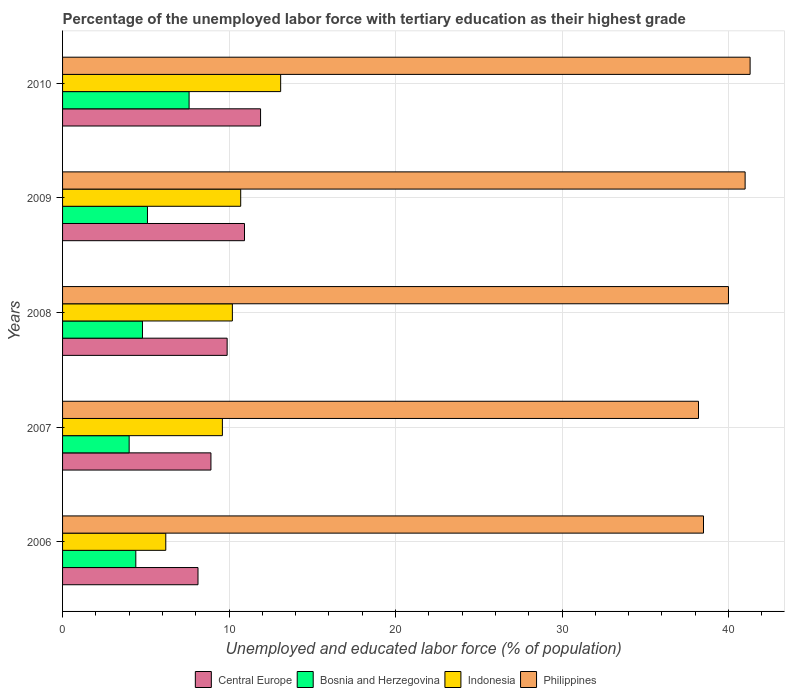How many different coloured bars are there?
Offer a terse response. 4. Are the number of bars per tick equal to the number of legend labels?
Your response must be concise. Yes. Are the number of bars on each tick of the Y-axis equal?
Provide a short and direct response. Yes. How many bars are there on the 2nd tick from the top?
Provide a succinct answer. 4. What is the percentage of the unemployed labor force with tertiary education in Philippines in 2007?
Keep it short and to the point. 38.2. Across all years, what is the maximum percentage of the unemployed labor force with tertiary education in Philippines?
Make the answer very short. 41.3. Across all years, what is the minimum percentage of the unemployed labor force with tertiary education in Central Europe?
Provide a succinct answer. 8.14. In which year was the percentage of the unemployed labor force with tertiary education in Indonesia minimum?
Keep it short and to the point. 2006. What is the total percentage of the unemployed labor force with tertiary education in Central Europe in the graph?
Offer a terse response. 49.76. What is the difference between the percentage of the unemployed labor force with tertiary education in Philippines in 2009 and that in 2010?
Your response must be concise. -0.3. What is the difference between the percentage of the unemployed labor force with tertiary education in Bosnia and Herzegovina in 2006 and the percentage of the unemployed labor force with tertiary education in Central Europe in 2007?
Your answer should be very brief. -4.51. What is the average percentage of the unemployed labor force with tertiary education in Philippines per year?
Your answer should be very brief. 39.8. In the year 2009, what is the difference between the percentage of the unemployed labor force with tertiary education in Philippines and percentage of the unemployed labor force with tertiary education in Bosnia and Herzegovina?
Provide a succinct answer. 35.9. What is the ratio of the percentage of the unemployed labor force with tertiary education in Philippines in 2008 to that in 2009?
Your response must be concise. 0.98. Is the difference between the percentage of the unemployed labor force with tertiary education in Philippines in 2008 and 2010 greater than the difference between the percentage of the unemployed labor force with tertiary education in Bosnia and Herzegovina in 2008 and 2010?
Give a very brief answer. Yes. What is the difference between the highest and the second highest percentage of the unemployed labor force with tertiary education in Philippines?
Offer a terse response. 0.3. What is the difference between the highest and the lowest percentage of the unemployed labor force with tertiary education in Bosnia and Herzegovina?
Provide a short and direct response. 3.6. In how many years, is the percentage of the unemployed labor force with tertiary education in Philippines greater than the average percentage of the unemployed labor force with tertiary education in Philippines taken over all years?
Provide a short and direct response. 3. Is the sum of the percentage of the unemployed labor force with tertiary education in Philippines in 2009 and 2010 greater than the maximum percentage of the unemployed labor force with tertiary education in Indonesia across all years?
Give a very brief answer. Yes. Is it the case that in every year, the sum of the percentage of the unemployed labor force with tertiary education in Philippines and percentage of the unemployed labor force with tertiary education in Indonesia is greater than the sum of percentage of the unemployed labor force with tertiary education in Bosnia and Herzegovina and percentage of the unemployed labor force with tertiary education in Central Europe?
Your response must be concise. Yes. What does the 3rd bar from the top in 2008 represents?
Give a very brief answer. Bosnia and Herzegovina. What does the 2nd bar from the bottom in 2008 represents?
Provide a short and direct response. Bosnia and Herzegovina. Is it the case that in every year, the sum of the percentage of the unemployed labor force with tertiary education in Philippines and percentage of the unemployed labor force with tertiary education in Indonesia is greater than the percentage of the unemployed labor force with tertiary education in Bosnia and Herzegovina?
Provide a succinct answer. Yes. How many bars are there?
Offer a very short reply. 20. Are all the bars in the graph horizontal?
Make the answer very short. Yes. How many years are there in the graph?
Your response must be concise. 5. What is the difference between two consecutive major ticks on the X-axis?
Provide a succinct answer. 10. Are the values on the major ticks of X-axis written in scientific E-notation?
Provide a succinct answer. No. Does the graph contain any zero values?
Provide a succinct answer. No. How many legend labels are there?
Give a very brief answer. 4. What is the title of the graph?
Keep it short and to the point. Percentage of the unemployed labor force with tertiary education as their highest grade. Does "Latin America(all income levels)" appear as one of the legend labels in the graph?
Your answer should be compact. No. What is the label or title of the X-axis?
Keep it short and to the point. Unemployed and educated labor force (% of population). What is the Unemployed and educated labor force (% of population) of Central Europe in 2006?
Offer a very short reply. 8.14. What is the Unemployed and educated labor force (% of population) of Bosnia and Herzegovina in 2006?
Your response must be concise. 4.4. What is the Unemployed and educated labor force (% of population) of Indonesia in 2006?
Give a very brief answer. 6.2. What is the Unemployed and educated labor force (% of population) of Philippines in 2006?
Provide a short and direct response. 38.5. What is the Unemployed and educated labor force (% of population) of Central Europe in 2007?
Your answer should be compact. 8.91. What is the Unemployed and educated labor force (% of population) of Bosnia and Herzegovina in 2007?
Your answer should be very brief. 4. What is the Unemployed and educated labor force (% of population) in Indonesia in 2007?
Ensure brevity in your answer.  9.6. What is the Unemployed and educated labor force (% of population) of Philippines in 2007?
Your answer should be very brief. 38.2. What is the Unemployed and educated labor force (% of population) in Central Europe in 2008?
Offer a terse response. 9.89. What is the Unemployed and educated labor force (% of population) in Bosnia and Herzegovina in 2008?
Offer a terse response. 4.8. What is the Unemployed and educated labor force (% of population) of Indonesia in 2008?
Your answer should be compact. 10.2. What is the Unemployed and educated labor force (% of population) in Central Europe in 2009?
Ensure brevity in your answer.  10.93. What is the Unemployed and educated labor force (% of population) of Bosnia and Herzegovina in 2009?
Ensure brevity in your answer.  5.1. What is the Unemployed and educated labor force (% of population) of Indonesia in 2009?
Make the answer very short. 10.7. What is the Unemployed and educated labor force (% of population) in Philippines in 2009?
Your answer should be compact. 41. What is the Unemployed and educated labor force (% of population) in Central Europe in 2010?
Make the answer very short. 11.89. What is the Unemployed and educated labor force (% of population) of Bosnia and Herzegovina in 2010?
Make the answer very short. 7.6. What is the Unemployed and educated labor force (% of population) of Indonesia in 2010?
Provide a succinct answer. 13.1. What is the Unemployed and educated labor force (% of population) in Philippines in 2010?
Provide a succinct answer. 41.3. Across all years, what is the maximum Unemployed and educated labor force (% of population) in Central Europe?
Provide a short and direct response. 11.89. Across all years, what is the maximum Unemployed and educated labor force (% of population) in Bosnia and Herzegovina?
Your response must be concise. 7.6. Across all years, what is the maximum Unemployed and educated labor force (% of population) of Indonesia?
Provide a short and direct response. 13.1. Across all years, what is the maximum Unemployed and educated labor force (% of population) of Philippines?
Your response must be concise. 41.3. Across all years, what is the minimum Unemployed and educated labor force (% of population) of Central Europe?
Your response must be concise. 8.14. Across all years, what is the minimum Unemployed and educated labor force (% of population) of Indonesia?
Make the answer very short. 6.2. Across all years, what is the minimum Unemployed and educated labor force (% of population) in Philippines?
Your answer should be compact. 38.2. What is the total Unemployed and educated labor force (% of population) of Central Europe in the graph?
Make the answer very short. 49.76. What is the total Unemployed and educated labor force (% of population) of Bosnia and Herzegovina in the graph?
Your answer should be compact. 25.9. What is the total Unemployed and educated labor force (% of population) of Indonesia in the graph?
Offer a very short reply. 49.8. What is the total Unemployed and educated labor force (% of population) in Philippines in the graph?
Give a very brief answer. 199. What is the difference between the Unemployed and educated labor force (% of population) of Central Europe in 2006 and that in 2007?
Offer a terse response. -0.78. What is the difference between the Unemployed and educated labor force (% of population) in Indonesia in 2006 and that in 2007?
Keep it short and to the point. -3.4. What is the difference between the Unemployed and educated labor force (% of population) of Central Europe in 2006 and that in 2008?
Ensure brevity in your answer.  -1.75. What is the difference between the Unemployed and educated labor force (% of population) of Bosnia and Herzegovina in 2006 and that in 2008?
Your response must be concise. -0.4. What is the difference between the Unemployed and educated labor force (% of population) in Indonesia in 2006 and that in 2008?
Ensure brevity in your answer.  -4. What is the difference between the Unemployed and educated labor force (% of population) of Philippines in 2006 and that in 2008?
Your answer should be very brief. -1.5. What is the difference between the Unemployed and educated labor force (% of population) of Central Europe in 2006 and that in 2009?
Offer a very short reply. -2.79. What is the difference between the Unemployed and educated labor force (% of population) of Central Europe in 2006 and that in 2010?
Provide a succinct answer. -3.76. What is the difference between the Unemployed and educated labor force (% of population) of Bosnia and Herzegovina in 2006 and that in 2010?
Offer a very short reply. -3.2. What is the difference between the Unemployed and educated labor force (% of population) in Central Europe in 2007 and that in 2008?
Provide a succinct answer. -0.97. What is the difference between the Unemployed and educated labor force (% of population) of Indonesia in 2007 and that in 2008?
Provide a short and direct response. -0.6. What is the difference between the Unemployed and educated labor force (% of population) in Philippines in 2007 and that in 2008?
Ensure brevity in your answer.  -1.8. What is the difference between the Unemployed and educated labor force (% of population) in Central Europe in 2007 and that in 2009?
Your answer should be very brief. -2.02. What is the difference between the Unemployed and educated labor force (% of population) of Bosnia and Herzegovina in 2007 and that in 2009?
Make the answer very short. -1.1. What is the difference between the Unemployed and educated labor force (% of population) in Indonesia in 2007 and that in 2009?
Provide a short and direct response. -1.1. What is the difference between the Unemployed and educated labor force (% of population) in Central Europe in 2007 and that in 2010?
Ensure brevity in your answer.  -2.98. What is the difference between the Unemployed and educated labor force (% of population) of Central Europe in 2008 and that in 2009?
Provide a succinct answer. -1.04. What is the difference between the Unemployed and educated labor force (% of population) of Indonesia in 2008 and that in 2009?
Keep it short and to the point. -0.5. What is the difference between the Unemployed and educated labor force (% of population) in Philippines in 2008 and that in 2009?
Make the answer very short. -1. What is the difference between the Unemployed and educated labor force (% of population) in Central Europe in 2008 and that in 2010?
Ensure brevity in your answer.  -2.01. What is the difference between the Unemployed and educated labor force (% of population) in Bosnia and Herzegovina in 2008 and that in 2010?
Give a very brief answer. -2.8. What is the difference between the Unemployed and educated labor force (% of population) in Indonesia in 2008 and that in 2010?
Your answer should be very brief. -2.9. What is the difference between the Unemployed and educated labor force (% of population) in Central Europe in 2009 and that in 2010?
Your answer should be very brief. -0.97. What is the difference between the Unemployed and educated labor force (% of population) of Indonesia in 2009 and that in 2010?
Make the answer very short. -2.4. What is the difference between the Unemployed and educated labor force (% of population) of Philippines in 2009 and that in 2010?
Provide a succinct answer. -0.3. What is the difference between the Unemployed and educated labor force (% of population) of Central Europe in 2006 and the Unemployed and educated labor force (% of population) of Bosnia and Herzegovina in 2007?
Your answer should be compact. 4.14. What is the difference between the Unemployed and educated labor force (% of population) in Central Europe in 2006 and the Unemployed and educated labor force (% of population) in Indonesia in 2007?
Provide a succinct answer. -1.46. What is the difference between the Unemployed and educated labor force (% of population) of Central Europe in 2006 and the Unemployed and educated labor force (% of population) of Philippines in 2007?
Your answer should be compact. -30.06. What is the difference between the Unemployed and educated labor force (% of population) of Bosnia and Herzegovina in 2006 and the Unemployed and educated labor force (% of population) of Philippines in 2007?
Your answer should be compact. -33.8. What is the difference between the Unemployed and educated labor force (% of population) in Indonesia in 2006 and the Unemployed and educated labor force (% of population) in Philippines in 2007?
Offer a very short reply. -32. What is the difference between the Unemployed and educated labor force (% of population) of Central Europe in 2006 and the Unemployed and educated labor force (% of population) of Bosnia and Herzegovina in 2008?
Ensure brevity in your answer.  3.34. What is the difference between the Unemployed and educated labor force (% of population) of Central Europe in 2006 and the Unemployed and educated labor force (% of population) of Indonesia in 2008?
Ensure brevity in your answer.  -2.06. What is the difference between the Unemployed and educated labor force (% of population) in Central Europe in 2006 and the Unemployed and educated labor force (% of population) in Philippines in 2008?
Give a very brief answer. -31.86. What is the difference between the Unemployed and educated labor force (% of population) in Bosnia and Herzegovina in 2006 and the Unemployed and educated labor force (% of population) in Indonesia in 2008?
Provide a short and direct response. -5.8. What is the difference between the Unemployed and educated labor force (% of population) of Bosnia and Herzegovina in 2006 and the Unemployed and educated labor force (% of population) of Philippines in 2008?
Give a very brief answer. -35.6. What is the difference between the Unemployed and educated labor force (% of population) in Indonesia in 2006 and the Unemployed and educated labor force (% of population) in Philippines in 2008?
Offer a very short reply. -33.8. What is the difference between the Unemployed and educated labor force (% of population) of Central Europe in 2006 and the Unemployed and educated labor force (% of population) of Bosnia and Herzegovina in 2009?
Ensure brevity in your answer.  3.04. What is the difference between the Unemployed and educated labor force (% of population) of Central Europe in 2006 and the Unemployed and educated labor force (% of population) of Indonesia in 2009?
Ensure brevity in your answer.  -2.56. What is the difference between the Unemployed and educated labor force (% of population) of Central Europe in 2006 and the Unemployed and educated labor force (% of population) of Philippines in 2009?
Provide a short and direct response. -32.86. What is the difference between the Unemployed and educated labor force (% of population) in Bosnia and Herzegovina in 2006 and the Unemployed and educated labor force (% of population) in Philippines in 2009?
Your response must be concise. -36.6. What is the difference between the Unemployed and educated labor force (% of population) in Indonesia in 2006 and the Unemployed and educated labor force (% of population) in Philippines in 2009?
Your response must be concise. -34.8. What is the difference between the Unemployed and educated labor force (% of population) in Central Europe in 2006 and the Unemployed and educated labor force (% of population) in Bosnia and Herzegovina in 2010?
Your answer should be compact. 0.54. What is the difference between the Unemployed and educated labor force (% of population) of Central Europe in 2006 and the Unemployed and educated labor force (% of population) of Indonesia in 2010?
Make the answer very short. -4.96. What is the difference between the Unemployed and educated labor force (% of population) of Central Europe in 2006 and the Unemployed and educated labor force (% of population) of Philippines in 2010?
Give a very brief answer. -33.16. What is the difference between the Unemployed and educated labor force (% of population) in Bosnia and Herzegovina in 2006 and the Unemployed and educated labor force (% of population) in Indonesia in 2010?
Provide a short and direct response. -8.7. What is the difference between the Unemployed and educated labor force (% of population) in Bosnia and Herzegovina in 2006 and the Unemployed and educated labor force (% of population) in Philippines in 2010?
Your answer should be compact. -36.9. What is the difference between the Unemployed and educated labor force (% of population) of Indonesia in 2006 and the Unemployed and educated labor force (% of population) of Philippines in 2010?
Keep it short and to the point. -35.1. What is the difference between the Unemployed and educated labor force (% of population) in Central Europe in 2007 and the Unemployed and educated labor force (% of population) in Bosnia and Herzegovina in 2008?
Offer a very short reply. 4.11. What is the difference between the Unemployed and educated labor force (% of population) in Central Europe in 2007 and the Unemployed and educated labor force (% of population) in Indonesia in 2008?
Keep it short and to the point. -1.29. What is the difference between the Unemployed and educated labor force (% of population) in Central Europe in 2007 and the Unemployed and educated labor force (% of population) in Philippines in 2008?
Make the answer very short. -31.09. What is the difference between the Unemployed and educated labor force (% of population) in Bosnia and Herzegovina in 2007 and the Unemployed and educated labor force (% of population) in Philippines in 2008?
Offer a very short reply. -36. What is the difference between the Unemployed and educated labor force (% of population) of Indonesia in 2007 and the Unemployed and educated labor force (% of population) of Philippines in 2008?
Offer a very short reply. -30.4. What is the difference between the Unemployed and educated labor force (% of population) of Central Europe in 2007 and the Unemployed and educated labor force (% of population) of Bosnia and Herzegovina in 2009?
Ensure brevity in your answer.  3.81. What is the difference between the Unemployed and educated labor force (% of population) in Central Europe in 2007 and the Unemployed and educated labor force (% of population) in Indonesia in 2009?
Make the answer very short. -1.79. What is the difference between the Unemployed and educated labor force (% of population) of Central Europe in 2007 and the Unemployed and educated labor force (% of population) of Philippines in 2009?
Your answer should be compact. -32.09. What is the difference between the Unemployed and educated labor force (% of population) in Bosnia and Herzegovina in 2007 and the Unemployed and educated labor force (% of population) in Indonesia in 2009?
Provide a short and direct response. -6.7. What is the difference between the Unemployed and educated labor force (% of population) in Bosnia and Herzegovina in 2007 and the Unemployed and educated labor force (% of population) in Philippines in 2009?
Provide a succinct answer. -37. What is the difference between the Unemployed and educated labor force (% of population) in Indonesia in 2007 and the Unemployed and educated labor force (% of population) in Philippines in 2009?
Give a very brief answer. -31.4. What is the difference between the Unemployed and educated labor force (% of population) of Central Europe in 2007 and the Unemployed and educated labor force (% of population) of Bosnia and Herzegovina in 2010?
Your response must be concise. 1.31. What is the difference between the Unemployed and educated labor force (% of population) of Central Europe in 2007 and the Unemployed and educated labor force (% of population) of Indonesia in 2010?
Give a very brief answer. -4.19. What is the difference between the Unemployed and educated labor force (% of population) of Central Europe in 2007 and the Unemployed and educated labor force (% of population) of Philippines in 2010?
Provide a succinct answer. -32.39. What is the difference between the Unemployed and educated labor force (% of population) in Bosnia and Herzegovina in 2007 and the Unemployed and educated labor force (% of population) in Philippines in 2010?
Provide a succinct answer. -37.3. What is the difference between the Unemployed and educated labor force (% of population) in Indonesia in 2007 and the Unemployed and educated labor force (% of population) in Philippines in 2010?
Make the answer very short. -31.7. What is the difference between the Unemployed and educated labor force (% of population) in Central Europe in 2008 and the Unemployed and educated labor force (% of population) in Bosnia and Herzegovina in 2009?
Keep it short and to the point. 4.79. What is the difference between the Unemployed and educated labor force (% of population) of Central Europe in 2008 and the Unemployed and educated labor force (% of population) of Indonesia in 2009?
Give a very brief answer. -0.81. What is the difference between the Unemployed and educated labor force (% of population) in Central Europe in 2008 and the Unemployed and educated labor force (% of population) in Philippines in 2009?
Your answer should be compact. -31.11. What is the difference between the Unemployed and educated labor force (% of population) in Bosnia and Herzegovina in 2008 and the Unemployed and educated labor force (% of population) in Indonesia in 2009?
Your answer should be compact. -5.9. What is the difference between the Unemployed and educated labor force (% of population) in Bosnia and Herzegovina in 2008 and the Unemployed and educated labor force (% of population) in Philippines in 2009?
Keep it short and to the point. -36.2. What is the difference between the Unemployed and educated labor force (% of population) in Indonesia in 2008 and the Unemployed and educated labor force (% of population) in Philippines in 2009?
Keep it short and to the point. -30.8. What is the difference between the Unemployed and educated labor force (% of population) in Central Europe in 2008 and the Unemployed and educated labor force (% of population) in Bosnia and Herzegovina in 2010?
Offer a terse response. 2.29. What is the difference between the Unemployed and educated labor force (% of population) in Central Europe in 2008 and the Unemployed and educated labor force (% of population) in Indonesia in 2010?
Give a very brief answer. -3.21. What is the difference between the Unemployed and educated labor force (% of population) in Central Europe in 2008 and the Unemployed and educated labor force (% of population) in Philippines in 2010?
Your response must be concise. -31.41. What is the difference between the Unemployed and educated labor force (% of population) of Bosnia and Herzegovina in 2008 and the Unemployed and educated labor force (% of population) of Indonesia in 2010?
Your answer should be compact. -8.3. What is the difference between the Unemployed and educated labor force (% of population) of Bosnia and Herzegovina in 2008 and the Unemployed and educated labor force (% of population) of Philippines in 2010?
Offer a terse response. -36.5. What is the difference between the Unemployed and educated labor force (% of population) in Indonesia in 2008 and the Unemployed and educated labor force (% of population) in Philippines in 2010?
Give a very brief answer. -31.1. What is the difference between the Unemployed and educated labor force (% of population) in Central Europe in 2009 and the Unemployed and educated labor force (% of population) in Bosnia and Herzegovina in 2010?
Provide a short and direct response. 3.33. What is the difference between the Unemployed and educated labor force (% of population) of Central Europe in 2009 and the Unemployed and educated labor force (% of population) of Indonesia in 2010?
Make the answer very short. -2.17. What is the difference between the Unemployed and educated labor force (% of population) in Central Europe in 2009 and the Unemployed and educated labor force (% of population) in Philippines in 2010?
Offer a very short reply. -30.37. What is the difference between the Unemployed and educated labor force (% of population) in Bosnia and Herzegovina in 2009 and the Unemployed and educated labor force (% of population) in Philippines in 2010?
Give a very brief answer. -36.2. What is the difference between the Unemployed and educated labor force (% of population) of Indonesia in 2009 and the Unemployed and educated labor force (% of population) of Philippines in 2010?
Keep it short and to the point. -30.6. What is the average Unemployed and educated labor force (% of population) in Central Europe per year?
Your response must be concise. 9.95. What is the average Unemployed and educated labor force (% of population) in Bosnia and Herzegovina per year?
Ensure brevity in your answer.  5.18. What is the average Unemployed and educated labor force (% of population) of Indonesia per year?
Offer a very short reply. 9.96. What is the average Unemployed and educated labor force (% of population) of Philippines per year?
Offer a terse response. 39.8. In the year 2006, what is the difference between the Unemployed and educated labor force (% of population) of Central Europe and Unemployed and educated labor force (% of population) of Bosnia and Herzegovina?
Your answer should be compact. 3.74. In the year 2006, what is the difference between the Unemployed and educated labor force (% of population) in Central Europe and Unemployed and educated labor force (% of population) in Indonesia?
Your answer should be compact. 1.94. In the year 2006, what is the difference between the Unemployed and educated labor force (% of population) of Central Europe and Unemployed and educated labor force (% of population) of Philippines?
Make the answer very short. -30.36. In the year 2006, what is the difference between the Unemployed and educated labor force (% of population) in Bosnia and Herzegovina and Unemployed and educated labor force (% of population) in Indonesia?
Provide a succinct answer. -1.8. In the year 2006, what is the difference between the Unemployed and educated labor force (% of population) of Bosnia and Herzegovina and Unemployed and educated labor force (% of population) of Philippines?
Offer a terse response. -34.1. In the year 2006, what is the difference between the Unemployed and educated labor force (% of population) in Indonesia and Unemployed and educated labor force (% of population) in Philippines?
Ensure brevity in your answer.  -32.3. In the year 2007, what is the difference between the Unemployed and educated labor force (% of population) in Central Europe and Unemployed and educated labor force (% of population) in Bosnia and Herzegovina?
Give a very brief answer. 4.91. In the year 2007, what is the difference between the Unemployed and educated labor force (% of population) of Central Europe and Unemployed and educated labor force (% of population) of Indonesia?
Give a very brief answer. -0.69. In the year 2007, what is the difference between the Unemployed and educated labor force (% of population) in Central Europe and Unemployed and educated labor force (% of population) in Philippines?
Offer a very short reply. -29.29. In the year 2007, what is the difference between the Unemployed and educated labor force (% of population) in Bosnia and Herzegovina and Unemployed and educated labor force (% of population) in Philippines?
Make the answer very short. -34.2. In the year 2007, what is the difference between the Unemployed and educated labor force (% of population) of Indonesia and Unemployed and educated labor force (% of population) of Philippines?
Offer a very short reply. -28.6. In the year 2008, what is the difference between the Unemployed and educated labor force (% of population) of Central Europe and Unemployed and educated labor force (% of population) of Bosnia and Herzegovina?
Provide a succinct answer. 5.09. In the year 2008, what is the difference between the Unemployed and educated labor force (% of population) of Central Europe and Unemployed and educated labor force (% of population) of Indonesia?
Offer a terse response. -0.31. In the year 2008, what is the difference between the Unemployed and educated labor force (% of population) in Central Europe and Unemployed and educated labor force (% of population) in Philippines?
Your answer should be compact. -30.11. In the year 2008, what is the difference between the Unemployed and educated labor force (% of population) of Bosnia and Herzegovina and Unemployed and educated labor force (% of population) of Indonesia?
Offer a very short reply. -5.4. In the year 2008, what is the difference between the Unemployed and educated labor force (% of population) of Bosnia and Herzegovina and Unemployed and educated labor force (% of population) of Philippines?
Provide a short and direct response. -35.2. In the year 2008, what is the difference between the Unemployed and educated labor force (% of population) in Indonesia and Unemployed and educated labor force (% of population) in Philippines?
Make the answer very short. -29.8. In the year 2009, what is the difference between the Unemployed and educated labor force (% of population) of Central Europe and Unemployed and educated labor force (% of population) of Bosnia and Herzegovina?
Offer a very short reply. 5.83. In the year 2009, what is the difference between the Unemployed and educated labor force (% of population) in Central Europe and Unemployed and educated labor force (% of population) in Indonesia?
Keep it short and to the point. 0.23. In the year 2009, what is the difference between the Unemployed and educated labor force (% of population) of Central Europe and Unemployed and educated labor force (% of population) of Philippines?
Your answer should be compact. -30.07. In the year 2009, what is the difference between the Unemployed and educated labor force (% of population) of Bosnia and Herzegovina and Unemployed and educated labor force (% of population) of Philippines?
Make the answer very short. -35.9. In the year 2009, what is the difference between the Unemployed and educated labor force (% of population) in Indonesia and Unemployed and educated labor force (% of population) in Philippines?
Offer a very short reply. -30.3. In the year 2010, what is the difference between the Unemployed and educated labor force (% of population) of Central Europe and Unemployed and educated labor force (% of population) of Bosnia and Herzegovina?
Your answer should be very brief. 4.29. In the year 2010, what is the difference between the Unemployed and educated labor force (% of population) in Central Europe and Unemployed and educated labor force (% of population) in Indonesia?
Make the answer very short. -1.21. In the year 2010, what is the difference between the Unemployed and educated labor force (% of population) in Central Europe and Unemployed and educated labor force (% of population) in Philippines?
Provide a succinct answer. -29.41. In the year 2010, what is the difference between the Unemployed and educated labor force (% of population) in Bosnia and Herzegovina and Unemployed and educated labor force (% of population) in Philippines?
Your response must be concise. -33.7. In the year 2010, what is the difference between the Unemployed and educated labor force (% of population) of Indonesia and Unemployed and educated labor force (% of population) of Philippines?
Your answer should be very brief. -28.2. What is the ratio of the Unemployed and educated labor force (% of population) of Central Europe in 2006 to that in 2007?
Your response must be concise. 0.91. What is the ratio of the Unemployed and educated labor force (% of population) of Indonesia in 2006 to that in 2007?
Provide a short and direct response. 0.65. What is the ratio of the Unemployed and educated labor force (% of population) in Philippines in 2006 to that in 2007?
Offer a very short reply. 1.01. What is the ratio of the Unemployed and educated labor force (% of population) in Central Europe in 2006 to that in 2008?
Provide a short and direct response. 0.82. What is the ratio of the Unemployed and educated labor force (% of population) in Indonesia in 2006 to that in 2008?
Give a very brief answer. 0.61. What is the ratio of the Unemployed and educated labor force (% of population) of Philippines in 2006 to that in 2008?
Give a very brief answer. 0.96. What is the ratio of the Unemployed and educated labor force (% of population) in Central Europe in 2006 to that in 2009?
Provide a short and direct response. 0.74. What is the ratio of the Unemployed and educated labor force (% of population) of Bosnia and Herzegovina in 2006 to that in 2009?
Your answer should be very brief. 0.86. What is the ratio of the Unemployed and educated labor force (% of population) in Indonesia in 2006 to that in 2009?
Your answer should be very brief. 0.58. What is the ratio of the Unemployed and educated labor force (% of population) in Philippines in 2006 to that in 2009?
Your answer should be very brief. 0.94. What is the ratio of the Unemployed and educated labor force (% of population) in Central Europe in 2006 to that in 2010?
Offer a very short reply. 0.68. What is the ratio of the Unemployed and educated labor force (% of population) of Bosnia and Herzegovina in 2006 to that in 2010?
Your answer should be compact. 0.58. What is the ratio of the Unemployed and educated labor force (% of population) of Indonesia in 2006 to that in 2010?
Provide a short and direct response. 0.47. What is the ratio of the Unemployed and educated labor force (% of population) in Philippines in 2006 to that in 2010?
Ensure brevity in your answer.  0.93. What is the ratio of the Unemployed and educated labor force (% of population) in Central Europe in 2007 to that in 2008?
Your answer should be compact. 0.9. What is the ratio of the Unemployed and educated labor force (% of population) in Philippines in 2007 to that in 2008?
Provide a short and direct response. 0.95. What is the ratio of the Unemployed and educated labor force (% of population) in Central Europe in 2007 to that in 2009?
Give a very brief answer. 0.82. What is the ratio of the Unemployed and educated labor force (% of population) of Bosnia and Herzegovina in 2007 to that in 2009?
Ensure brevity in your answer.  0.78. What is the ratio of the Unemployed and educated labor force (% of population) of Indonesia in 2007 to that in 2009?
Offer a terse response. 0.9. What is the ratio of the Unemployed and educated labor force (% of population) of Philippines in 2007 to that in 2009?
Offer a very short reply. 0.93. What is the ratio of the Unemployed and educated labor force (% of population) in Central Europe in 2007 to that in 2010?
Provide a succinct answer. 0.75. What is the ratio of the Unemployed and educated labor force (% of population) of Bosnia and Herzegovina in 2007 to that in 2010?
Offer a terse response. 0.53. What is the ratio of the Unemployed and educated labor force (% of population) in Indonesia in 2007 to that in 2010?
Your answer should be compact. 0.73. What is the ratio of the Unemployed and educated labor force (% of population) in Philippines in 2007 to that in 2010?
Ensure brevity in your answer.  0.92. What is the ratio of the Unemployed and educated labor force (% of population) of Central Europe in 2008 to that in 2009?
Provide a succinct answer. 0.9. What is the ratio of the Unemployed and educated labor force (% of population) in Bosnia and Herzegovina in 2008 to that in 2009?
Provide a succinct answer. 0.94. What is the ratio of the Unemployed and educated labor force (% of population) of Indonesia in 2008 to that in 2009?
Offer a very short reply. 0.95. What is the ratio of the Unemployed and educated labor force (% of population) in Philippines in 2008 to that in 2009?
Provide a short and direct response. 0.98. What is the ratio of the Unemployed and educated labor force (% of population) in Central Europe in 2008 to that in 2010?
Your response must be concise. 0.83. What is the ratio of the Unemployed and educated labor force (% of population) in Bosnia and Herzegovina in 2008 to that in 2010?
Make the answer very short. 0.63. What is the ratio of the Unemployed and educated labor force (% of population) in Indonesia in 2008 to that in 2010?
Ensure brevity in your answer.  0.78. What is the ratio of the Unemployed and educated labor force (% of population) in Philippines in 2008 to that in 2010?
Provide a short and direct response. 0.97. What is the ratio of the Unemployed and educated labor force (% of population) of Central Europe in 2009 to that in 2010?
Offer a terse response. 0.92. What is the ratio of the Unemployed and educated labor force (% of population) of Bosnia and Herzegovina in 2009 to that in 2010?
Ensure brevity in your answer.  0.67. What is the ratio of the Unemployed and educated labor force (% of population) of Indonesia in 2009 to that in 2010?
Provide a short and direct response. 0.82. What is the difference between the highest and the second highest Unemployed and educated labor force (% of population) in Central Europe?
Provide a short and direct response. 0.97. What is the difference between the highest and the second highest Unemployed and educated labor force (% of population) of Bosnia and Herzegovina?
Provide a short and direct response. 2.5. What is the difference between the highest and the lowest Unemployed and educated labor force (% of population) of Central Europe?
Give a very brief answer. 3.76. What is the difference between the highest and the lowest Unemployed and educated labor force (% of population) of Indonesia?
Give a very brief answer. 6.9. What is the difference between the highest and the lowest Unemployed and educated labor force (% of population) in Philippines?
Provide a succinct answer. 3.1. 